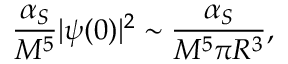Convert formula to latex. <formula><loc_0><loc_0><loc_500><loc_500>{ \frac { \alpha _ { S } } { M ^ { 5 } } } | \psi ( 0 ) | ^ { 2 } \sim { \frac { \alpha _ { S } } { M ^ { 5 } \pi R ^ { 3 } } } ,</formula> 